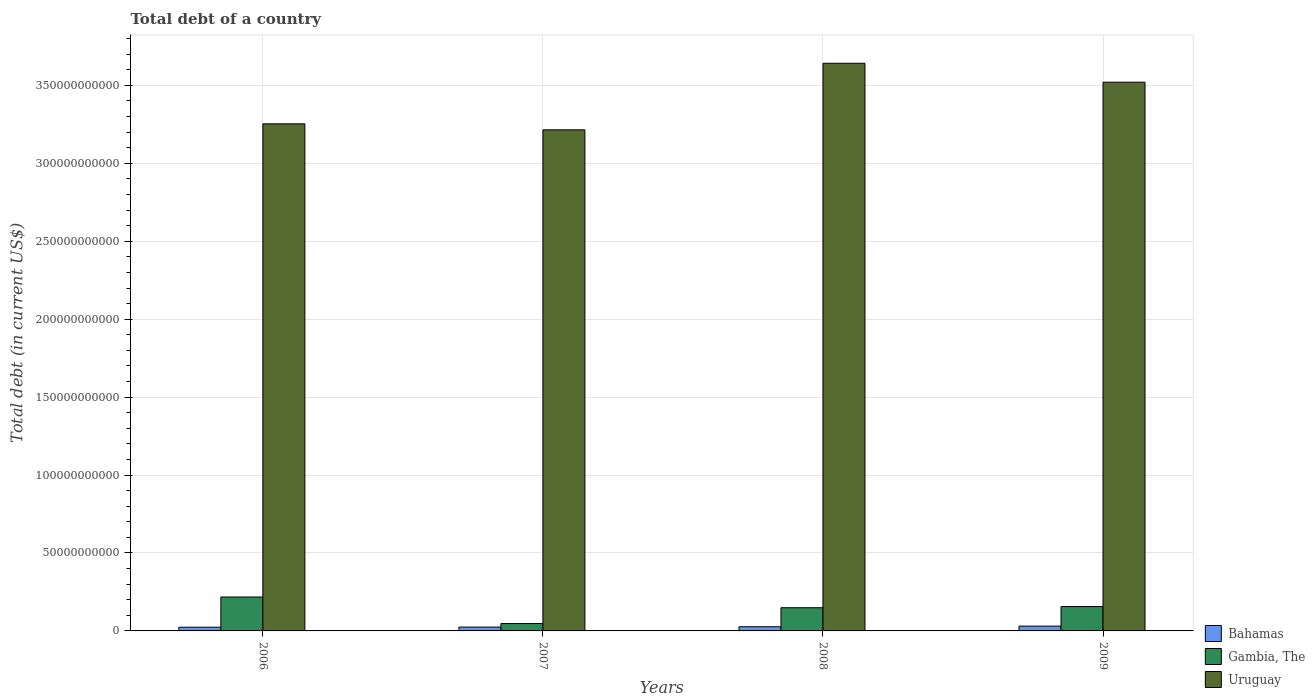How many groups of bars are there?
Keep it short and to the point. 4. Are the number of bars per tick equal to the number of legend labels?
Keep it short and to the point. Yes. How many bars are there on the 4th tick from the right?
Provide a succinct answer. 3. What is the label of the 1st group of bars from the left?
Offer a very short reply. 2006. In how many cases, is the number of bars for a given year not equal to the number of legend labels?
Offer a terse response. 0. What is the debt in Uruguay in 2007?
Provide a short and direct response. 3.22e+11. Across all years, what is the maximum debt in Gambia, The?
Offer a very short reply. 2.18e+1. Across all years, what is the minimum debt in Bahamas?
Offer a very short reply. 2.39e+09. In which year was the debt in Bahamas maximum?
Your answer should be compact. 2009. In which year was the debt in Uruguay minimum?
Your answer should be compact. 2007. What is the total debt in Bahamas in the graph?
Offer a terse response. 1.06e+1. What is the difference between the debt in Bahamas in 2006 and that in 2007?
Your answer should be compact. -8.30e+07. What is the difference between the debt in Bahamas in 2008 and the debt in Uruguay in 2009?
Keep it short and to the point. -3.49e+11. What is the average debt in Bahamas per year?
Make the answer very short. 2.65e+09. In the year 2007, what is the difference between the debt in Gambia, The and debt in Bahamas?
Offer a very short reply. 2.27e+09. In how many years, is the debt in Gambia, The greater than 310000000000 US$?
Your response must be concise. 0. What is the ratio of the debt in Bahamas in 2007 to that in 2008?
Ensure brevity in your answer.  0.92. Is the difference between the debt in Gambia, The in 2008 and 2009 greater than the difference between the debt in Bahamas in 2008 and 2009?
Your answer should be compact. No. What is the difference between the highest and the second highest debt in Uruguay?
Ensure brevity in your answer.  1.21e+1. What is the difference between the highest and the lowest debt in Gambia, The?
Your answer should be compact. 1.70e+1. What does the 2nd bar from the left in 2009 represents?
Offer a terse response. Gambia, The. What does the 3rd bar from the right in 2008 represents?
Make the answer very short. Bahamas. Is it the case that in every year, the sum of the debt in Uruguay and debt in Bahamas is greater than the debt in Gambia, The?
Provide a short and direct response. Yes. Are all the bars in the graph horizontal?
Offer a terse response. No. Are the values on the major ticks of Y-axis written in scientific E-notation?
Give a very brief answer. No. Does the graph contain any zero values?
Offer a terse response. No. Does the graph contain grids?
Your answer should be very brief. Yes. Where does the legend appear in the graph?
Ensure brevity in your answer.  Bottom right. How many legend labels are there?
Ensure brevity in your answer.  3. How are the legend labels stacked?
Make the answer very short. Vertical. What is the title of the graph?
Your answer should be very brief. Total debt of a country. Does "Least developed countries" appear as one of the legend labels in the graph?
Offer a terse response. No. What is the label or title of the Y-axis?
Give a very brief answer. Total debt (in current US$). What is the Total debt (in current US$) in Bahamas in 2006?
Provide a short and direct response. 2.39e+09. What is the Total debt (in current US$) of Gambia, The in 2006?
Make the answer very short. 2.18e+1. What is the Total debt (in current US$) in Uruguay in 2006?
Your answer should be compact. 3.25e+11. What is the Total debt (in current US$) of Bahamas in 2007?
Your response must be concise. 2.47e+09. What is the Total debt (in current US$) in Gambia, The in 2007?
Provide a short and direct response. 4.74e+09. What is the Total debt (in current US$) in Uruguay in 2007?
Ensure brevity in your answer.  3.22e+11. What is the Total debt (in current US$) of Bahamas in 2008?
Offer a very short reply. 2.68e+09. What is the Total debt (in current US$) in Gambia, The in 2008?
Your response must be concise. 1.49e+1. What is the Total debt (in current US$) in Uruguay in 2008?
Ensure brevity in your answer.  3.64e+11. What is the Total debt (in current US$) in Bahamas in 2009?
Ensure brevity in your answer.  3.08e+09. What is the Total debt (in current US$) in Gambia, The in 2009?
Make the answer very short. 1.56e+1. What is the Total debt (in current US$) in Uruguay in 2009?
Your response must be concise. 3.52e+11. Across all years, what is the maximum Total debt (in current US$) of Bahamas?
Your response must be concise. 3.08e+09. Across all years, what is the maximum Total debt (in current US$) of Gambia, The?
Offer a very short reply. 2.18e+1. Across all years, what is the maximum Total debt (in current US$) of Uruguay?
Offer a very short reply. 3.64e+11. Across all years, what is the minimum Total debt (in current US$) of Bahamas?
Your answer should be very brief. 2.39e+09. Across all years, what is the minimum Total debt (in current US$) in Gambia, The?
Your response must be concise. 4.74e+09. Across all years, what is the minimum Total debt (in current US$) in Uruguay?
Your answer should be compact. 3.22e+11. What is the total Total debt (in current US$) of Bahamas in the graph?
Keep it short and to the point. 1.06e+1. What is the total Total debt (in current US$) in Gambia, The in the graph?
Provide a short and direct response. 5.70e+1. What is the total Total debt (in current US$) in Uruguay in the graph?
Your response must be concise. 1.36e+12. What is the difference between the Total debt (in current US$) of Bahamas in 2006 and that in 2007?
Your answer should be very brief. -8.30e+07. What is the difference between the Total debt (in current US$) of Gambia, The in 2006 and that in 2007?
Offer a terse response. 1.70e+1. What is the difference between the Total debt (in current US$) in Uruguay in 2006 and that in 2007?
Keep it short and to the point. 3.85e+09. What is the difference between the Total debt (in current US$) of Bahamas in 2006 and that in 2008?
Offer a very short reply. -2.93e+08. What is the difference between the Total debt (in current US$) in Gambia, The in 2006 and that in 2008?
Provide a short and direct response. 6.89e+09. What is the difference between the Total debt (in current US$) in Uruguay in 2006 and that in 2008?
Keep it short and to the point. -3.89e+1. What is the difference between the Total debt (in current US$) in Bahamas in 2006 and that in 2009?
Offer a terse response. -6.98e+08. What is the difference between the Total debt (in current US$) in Gambia, The in 2006 and that in 2009?
Provide a succinct answer. 6.16e+09. What is the difference between the Total debt (in current US$) of Uruguay in 2006 and that in 2009?
Provide a short and direct response. -2.67e+1. What is the difference between the Total debt (in current US$) in Bahamas in 2007 and that in 2008?
Your answer should be compact. -2.10e+08. What is the difference between the Total debt (in current US$) of Gambia, The in 2007 and that in 2008?
Your answer should be compact. -1.01e+1. What is the difference between the Total debt (in current US$) of Uruguay in 2007 and that in 2008?
Give a very brief answer. -4.27e+1. What is the difference between the Total debt (in current US$) of Bahamas in 2007 and that in 2009?
Make the answer very short. -6.15e+08. What is the difference between the Total debt (in current US$) in Gambia, The in 2007 and that in 2009?
Make the answer very short. -1.09e+1. What is the difference between the Total debt (in current US$) in Uruguay in 2007 and that in 2009?
Offer a terse response. -3.06e+1. What is the difference between the Total debt (in current US$) of Bahamas in 2008 and that in 2009?
Your answer should be compact. -4.06e+08. What is the difference between the Total debt (in current US$) of Gambia, The in 2008 and that in 2009?
Make the answer very short. -7.27e+08. What is the difference between the Total debt (in current US$) of Uruguay in 2008 and that in 2009?
Offer a very short reply. 1.21e+1. What is the difference between the Total debt (in current US$) in Bahamas in 2006 and the Total debt (in current US$) in Gambia, The in 2007?
Keep it short and to the point. -2.36e+09. What is the difference between the Total debt (in current US$) in Bahamas in 2006 and the Total debt (in current US$) in Uruguay in 2007?
Offer a terse response. -3.19e+11. What is the difference between the Total debt (in current US$) in Gambia, The in 2006 and the Total debt (in current US$) in Uruguay in 2007?
Your response must be concise. -3.00e+11. What is the difference between the Total debt (in current US$) of Bahamas in 2006 and the Total debt (in current US$) of Gambia, The in 2008?
Your answer should be very brief. -1.25e+1. What is the difference between the Total debt (in current US$) of Bahamas in 2006 and the Total debt (in current US$) of Uruguay in 2008?
Offer a terse response. -3.62e+11. What is the difference between the Total debt (in current US$) in Gambia, The in 2006 and the Total debt (in current US$) in Uruguay in 2008?
Give a very brief answer. -3.42e+11. What is the difference between the Total debt (in current US$) of Bahamas in 2006 and the Total debt (in current US$) of Gambia, The in 2009?
Ensure brevity in your answer.  -1.32e+1. What is the difference between the Total debt (in current US$) of Bahamas in 2006 and the Total debt (in current US$) of Uruguay in 2009?
Your answer should be very brief. -3.50e+11. What is the difference between the Total debt (in current US$) in Gambia, The in 2006 and the Total debt (in current US$) in Uruguay in 2009?
Offer a very short reply. -3.30e+11. What is the difference between the Total debt (in current US$) of Bahamas in 2007 and the Total debt (in current US$) of Gambia, The in 2008?
Make the answer very short. -1.24e+1. What is the difference between the Total debt (in current US$) of Bahamas in 2007 and the Total debt (in current US$) of Uruguay in 2008?
Make the answer very short. -3.62e+11. What is the difference between the Total debt (in current US$) in Gambia, The in 2007 and the Total debt (in current US$) in Uruguay in 2008?
Offer a very short reply. -3.59e+11. What is the difference between the Total debt (in current US$) in Bahamas in 2007 and the Total debt (in current US$) in Gambia, The in 2009?
Provide a short and direct response. -1.31e+1. What is the difference between the Total debt (in current US$) of Bahamas in 2007 and the Total debt (in current US$) of Uruguay in 2009?
Give a very brief answer. -3.50e+11. What is the difference between the Total debt (in current US$) of Gambia, The in 2007 and the Total debt (in current US$) of Uruguay in 2009?
Make the answer very short. -3.47e+11. What is the difference between the Total debt (in current US$) in Bahamas in 2008 and the Total debt (in current US$) in Gambia, The in 2009?
Offer a very short reply. -1.29e+1. What is the difference between the Total debt (in current US$) in Bahamas in 2008 and the Total debt (in current US$) in Uruguay in 2009?
Your response must be concise. -3.49e+11. What is the difference between the Total debt (in current US$) of Gambia, The in 2008 and the Total debt (in current US$) of Uruguay in 2009?
Offer a terse response. -3.37e+11. What is the average Total debt (in current US$) of Bahamas per year?
Give a very brief answer. 2.65e+09. What is the average Total debt (in current US$) of Gambia, The per year?
Your answer should be compact. 1.43e+1. What is the average Total debt (in current US$) of Uruguay per year?
Give a very brief answer. 3.41e+11. In the year 2006, what is the difference between the Total debt (in current US$) in Bahamas and Total debt (in current US$) in Gambia, The?
Your answer should be compact. -1.94e+1. In the year 2006, what is the difference between the Total debt (in current US$) in Bahamas and Total debt (in current US$) in Uruguay?
Keep it short and to the point. -3.23e+11. In the year 2006, what is the difference between the Total debt (in current US$) in Gambia, The and Total debt (in current US$) in Uruguay?
Make the answer very short. -3.04e+11. In the year 2007, what is the difference between the Total debt (in current US$) in Bahamas and Total debt (in current US$) in Gambia, The?
Provide a succinct answer. -2.27e+09. In the year 2007, what is the difference between the Total debt (in current US$) in Bahamas and Total debt (in current US$) in Uruguay?
Offer a very short reply. -3.19e+11. In the year 2007, what is the difference between the Total debt (in current US$) of Gambia, The and Total debt (in current US$) of Uruguay?
Your response must be concise. -3.17e+11. In the year 2008, what is the difference between the Total debt (in current US$) in Bahamas and Total debt (in current US$) in Gambia, The?
Provide a short and direct response. -1.22e+1. In the year 2008, what is the difference between the Total debt (in current US$) of Bahamas and Total debt (in current US$) of Uruguay?
Give a very brief answer. -3.62e+11. In the year 2008, what is the difference between the Total debt (in current US$) in Gambia, The and Total debt (in current US$) in Uruguay?
Provide a short and direct response. -3.49e+11. In the year 2009, what is the difference between the Total debt (in current US$) of Bahamas and Total debt (in current US$) of Gambia, The?
Offer a terse response. -1.25e+1. In the year 2009, what is the difference between the Total debt (in current US$) in Bahamas and Total debt (in current US$) in Uruguay?
Offer a terse response. -3.49e+11. In the year 2009, what is the difference between the Total debt (in current US$) in Gambia, The and Total debt (in current US$) in Uruguay?
Your answer should be very brief. -3.36e+11. What is the ratio of the Total debt (in current US$) of Bahamas in 2006 to that in 2007?
Your answer should be very brief. 0.97. What is the ratio of the Total debt (in current US$) of Gambia, The in 2006 to that in 2007?
Give a very brief answer. 4.59. What is the ratio of the Total debt (in current US$) of Bahamas in 2006 to that in 2008?
Keep it short and to the point. 0.89. What is the ratio of the Total debt (in current US$) of Gambia, The in 2006 to that in 2008?
Provide a succinct answer. 1.46. What is the ratio of the Total debt (in current US$) of Uruguay in 2006 to that in 2008?
Provide a short and direct response. 0.89. What is the ratio of the Total debt (in current US$) of Bahamas in 2006 to that in 2009?
Give a very brief answer. 0.77. What is the ratio of the Total debt (in current US$) of Gambia, The in 2006 to that in 2009?
Your response must be concise. 1.39. What is the ratio of the Total debt (in current US$) in Uruguay in 2006 to that in 2009?
Your response must be concise. 0.92. What is the ratio of the Total debt (in current US$) in Bahamas in 2007 to that in 2008?
Make the answer very short. 0.92. What is the ratio of the Total debt (in current US$) of Gambia, The in 2007 to that in 2008?
Offer a very short reply. 0.32. What is the ratio of the Total debt (in current US$) in Uruguay in 2007 to that in 2008?
Your answer should be very brief. 0.88. What is the ratio of the Total debt (in current US$) of Bahamas in 2007 to that in 2009?
Make the answer very short. 0.8. What is the ratio of the Total debt (in current US$) in Gambia, The in 2007 to that in 2009?
Keep it short and to the point. 0.3. What is the ratio of the Total debt (in current US$) in Uruguay in 2007 to that in 2009?
Offer a very short reply. 0.91. What is the ratio of the Total debt (in current US$) of Bahamas in 2008 to that in 2009?
Provide a short and direct response. 0.87. What is the ratio of the Total debt (in current US$) in Gambia, The in 2008 to that in 2009?
Keep it short and to the point. 0.95. What is the ratio of the Total debt (in current US$) of Uruguay in 2008 to that in 2009?
Your answer should be compact. 1.03. What is the difference between the highest and the second highest Total debt (in current US$) in Bahamas?
Make the answer very short. 4.06e+08. What is the difference between the highest and the second highest Total debt (in current US$) of Gambia, The?
Your answer should be compact. 6.16e+09. What is the difference between the highest and the second highest Total debt (in current US$) in Uruguay?
Provide a succinct answer. 1.21e+1. What is the difference between the highest and the lowest Total debt (in current US$) in Bahamas?
Your response must be concise. 6.98e+08. What is the difference between the highest and the lowest Total debt (in current US$) in Gambia, The?
Offer a terse response. 1.70e+1. What is the difference between the highest and the lowest Total debt (in current US$) of Uruguay?
Your response must be concise. 4.27e+1. 